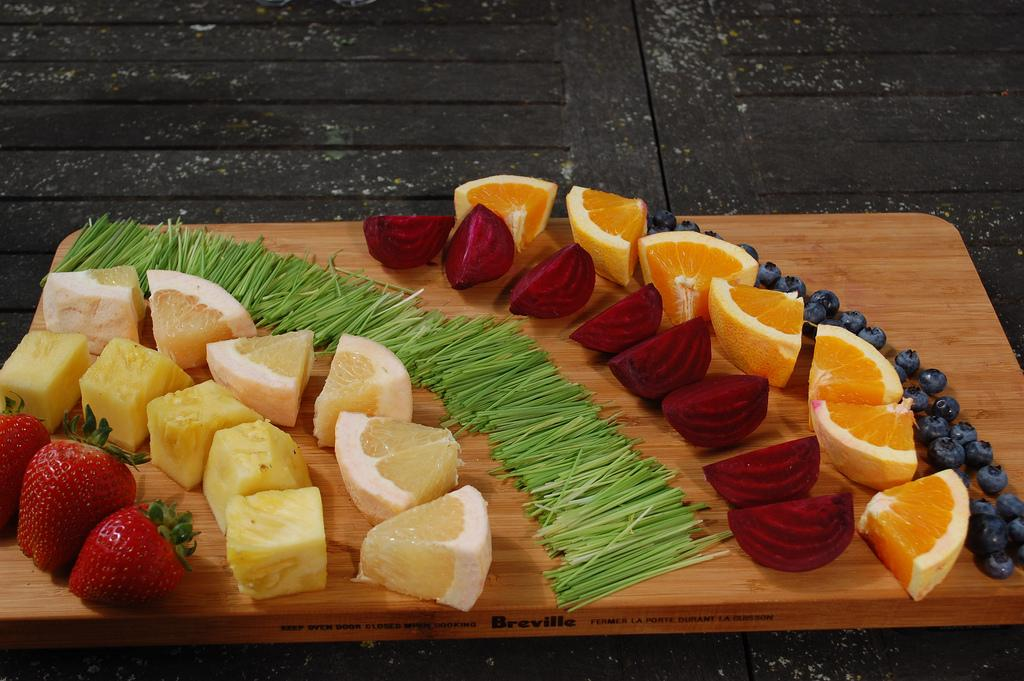What type of items can be seen in the image? There are food items in the image. What is the surface made of that the food items are on? The food items are on a wooden surface. Can you describe the black object in the image? There is a black object in the image. How is the wooden surface related to the black object? The wooden surface is on the black object. What does your uncle wish for in the image? There is no reference to an uncle or any wishes in the image, so it's not possible to answer that question. 